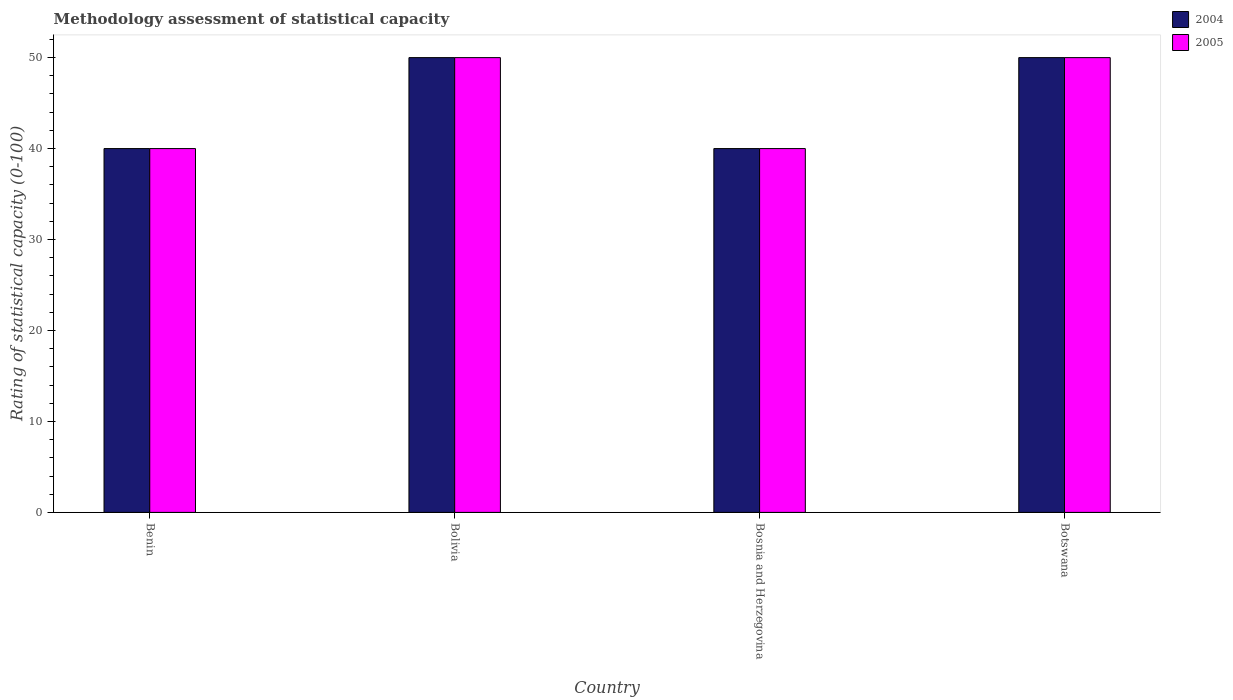How many bars are there on the 3rd tick from the left?
Your answer should be very brief. 2. What is the label of the 2nd group of bars from the left?
Make the answer very short. Bolivia. Across all countries, what is the maximum rating of statistical capacity in 2004?
Ensure brevity in your answer.  50. Across all countries, what is the minimum rating of statistical capacity in 2004?
Make the answer very short. 40. In which country was the rating of statistical capacity in 2005 minimum?
Make the answer very short. Benin. What is the total rating of statistical capacity in 2005 in the graph?
Give a very brief answer. 180. What is the difference between the rating of statistical capacity in 2004 in Benin and that in Botswana?
Your answer should be very brief. -10. What is the difference between the rating of statistical capacity in 2004 in Benin and the rating of statistical capacity in 2005 in Bosnia and Herzegovina?
Make the answer very short. 0. In how many countries, is the rating of statistical capacity in 2004 greater than 42?
Your answer should be very brief. 2. Is the rating of statistical capacity in 2005 in Benin less than that in Bolivia?
Give a very brief answer. Yes. What is the difference between the highest and the second highest rating of statistical capacity in 2004?
Provide a succinct answer. -10. What does the 1st bar from the left in Benin represents?
Give a very brief answer. 2004. How many countries are there in the graph?
Provide a short and direct response. 4. How many legend labels are there?
Offer a terse response. 2. How are the legend labels stacked?
Your answer should be very brief. Vertical. What is the title of the graph?
Keep it short and to the point. Methodology assessment of statistical capacity. Does "1983" appear as one of the legend labels in the graph?
Your answer should be very brief. No. What is the label or title of the Y-axis?
Provide a short and direct response. Rating of statistical capacity (0-100). What is the Rating of statistical capacity (0-100) in 2004 in Benin?
Give a very brief answer. 40. What is the Rating of statistical capacity (0-100) in 2005 in Bosnia and Herzegovina?
Keep it short and to the point. 40. What is the Rating of statistical capacity (0-100) of 2004 in Botswana?
Your answer should be very brief. 50. Across all countries, what is the maximum Rating of statistical capacity (0-100) in 2004?
Your answer should be very brief. 50. What is the total Rating of statistical capacity (0-100) of 2004 in the graph?
Make the answer very short. 180. What is the total Rating of statistical capacity (0-100) in 2005 in the graph?
Provide a short and direct response. 180. What is the difference between the Rating of statistical capacity (0-100) of 2004 in Benin and that in Bolivia?
Provide a succinct answer. -10. What is the difference between the Rating of statistical capacity (0-100) of 2005 in Benin and that in Bolivia?
Your answer should be very brief. -10. What is the difference between the Rating of statistical capacity (0-100) of 2004 in Benin and that in Bosnia and Herzegovina?
Make the answer very short. 0. What is the difference between the Rating of statistical capacity (0-100) of 2005 in Benin and that in Bosnia and Herzegovina?
Provide a succinct answer. 0. What is the difference between the Rating of statistical capacity (0-100) of 2005 in Benin and that in Botswana?
Your answer should be very brief. -10. What is the difference between the Rating of statistical capacity (0-100) in 2004 in Bolivia and that in Bosnia and Herzegovina?
Provide a short and direct response. 10. What is the difference between the Rating of statistical capacity (0-100) of 2005 in Bolivia and that in Bosnia and Herzegovina?
Ensure brevity in your answer.  10. What is the difference between the Rating of statistical capacity (0-100) of 2004 in Bosnia and Herzegovina and that in Botswana?
Your response must be concise. -10. What is the difference between the Rating of statistical capacity (0-100) of 2005 in Bosnia and Herzegovina and that in Botswana?
Ensure brevity in your answer.  -10. What is the difference between the Rating of statistical capacity (0-100) of 2004 and Rating of statistical capacity (0-100) of 2005 in Botswana?
Your response must be concise. 0. What is the ratio of the Rating of statistical capacity (0-100) of 2004 in Benin to that in Bolivia?
Provide a succinct answer. 0.8. What is the ratio of the Rating of statistical capacity (0-100) in 2004 in Bolivia to that in Bosnia and Herzegovina?
Your answer should be very brief. 1.25. What is the ratio of the Rating of statistical capacity (0-100) of 2004 in Bosnia and Herzegovina to that in Botswana?
Offer a terse response. 0.8. What is the ratio of the Rating of statistical capacity (0-100) in 2005 in Bosnia and Herzegovina to that in Botswana?
Your response must be concise. 0.8. What is the difference between the highest and the second highest Rating of statistical capacity (0-100) of 2005?
Give a very brief answer. 0. 